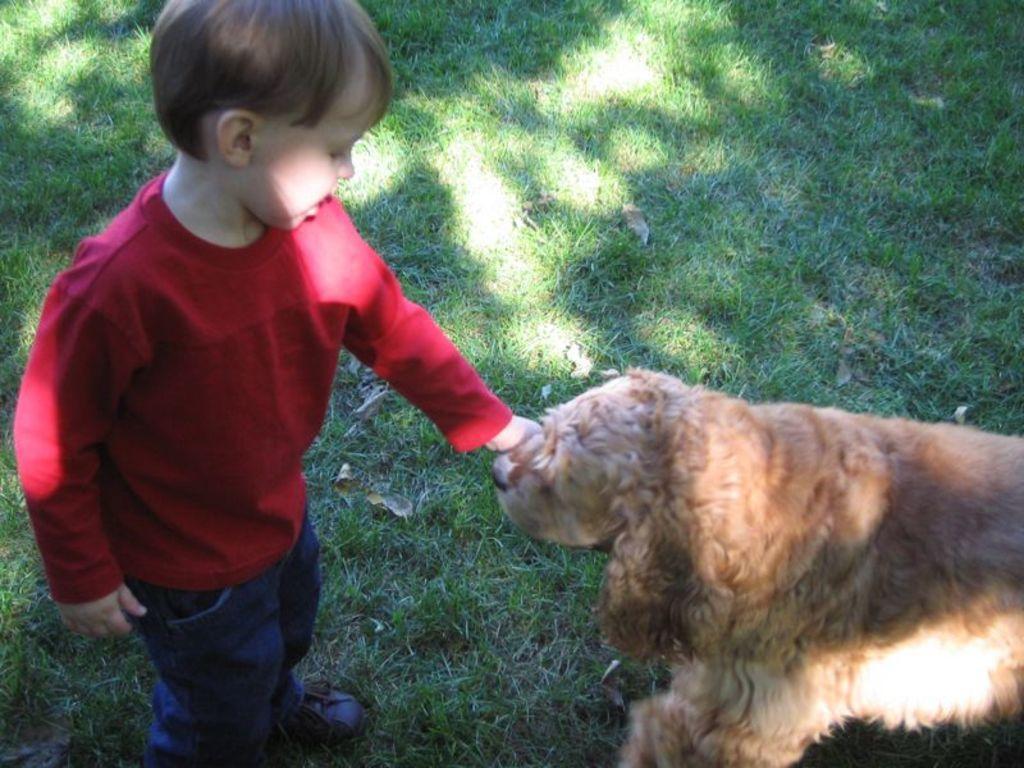Could you give a brief overview of what you see in this image? This is a picture of a boy catching a dog ,in background there is a grass. 